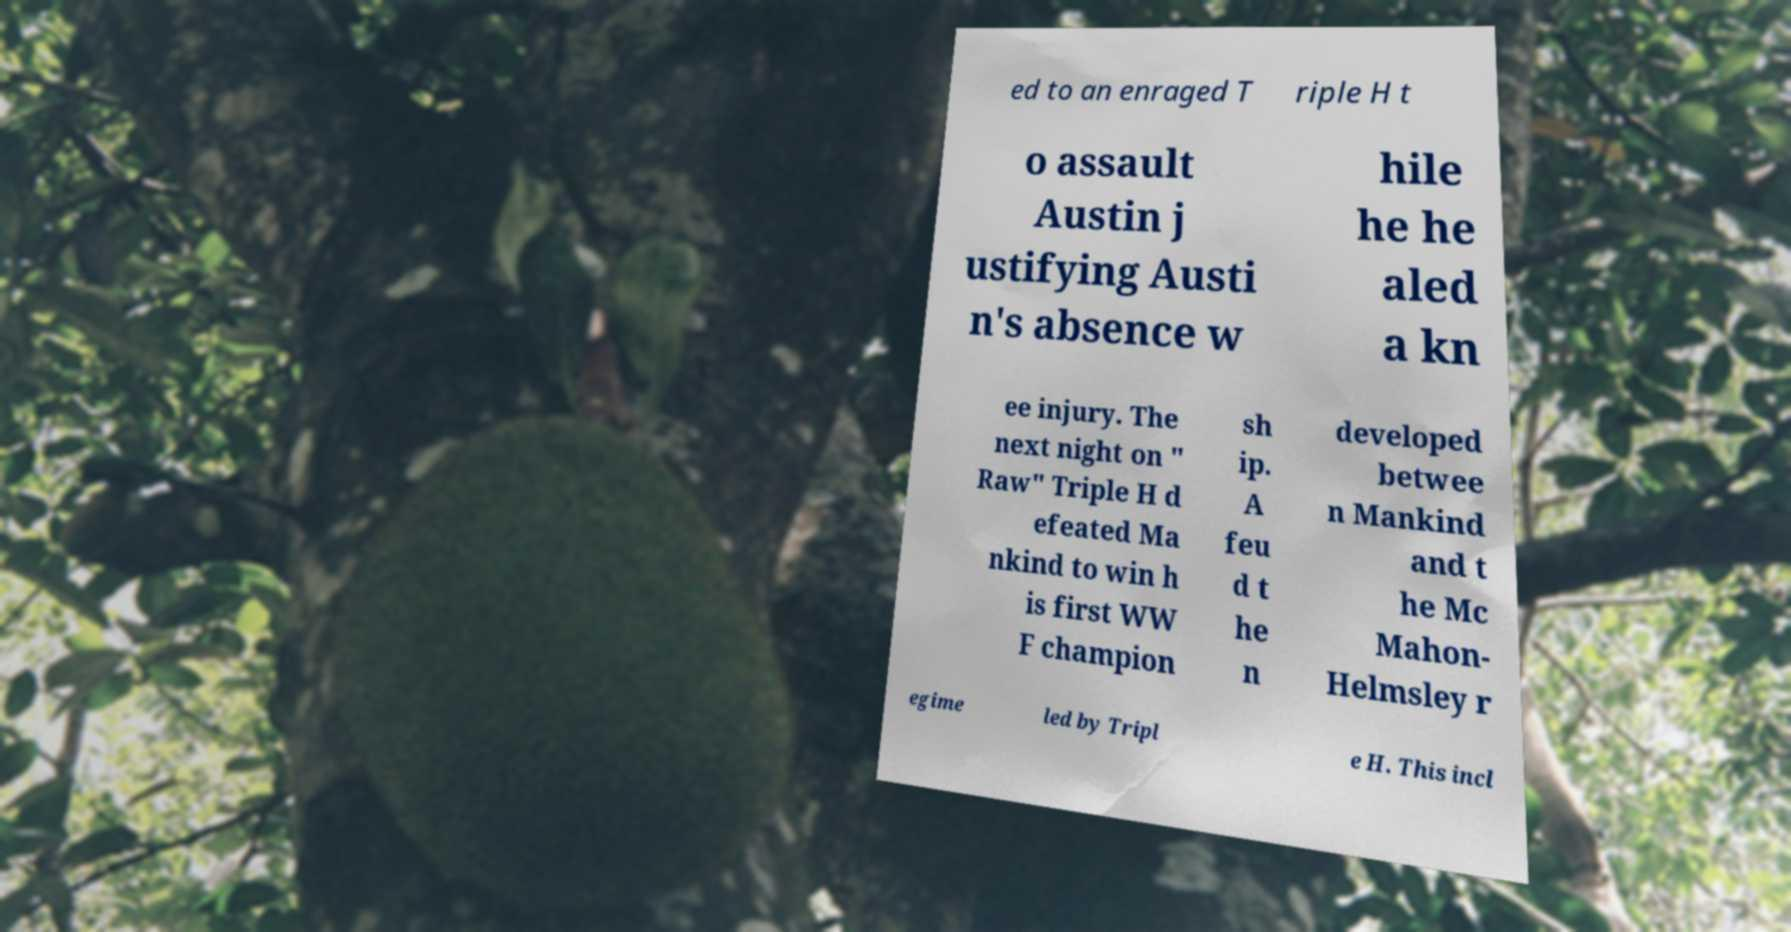What messages or text are displayed in this image? I need them in a readable, typed format. ed to an enraged T riple H t o assault Austin j ustifying Austi n's absence w hile he he aled a kn ee injury. The next night on " Raw" Triple H d efeated Ma nkind to win h is first WW F champion sh ip. A feu d t he n developed betwee n Mankind and t he Mc Mahon- Helmsley r egime led by Tripl e H. This incl 